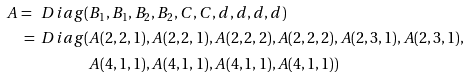<formula> <loc_0><loc_0><loc_500><loc_500>A = \ D i a g ( & B _ { 1 } , B _ { 1 } , B _ { 2 } , B _ { 2 } , C , C , d , d , d , d ) \\ = \ D i a g ( & A ( 2 , 2 , 1 ) , A ( 2 , 2 , 1 ) , A ( 2 , 2 , 2 ) , A ( 2 , 2 , 2 ) , A ( 2 , 3 , 1 ) , A ( 2 , 3 , 1 ) , \\ & A ( 4 , 1 , 1 ) , A ( 4 , 1 , 1 ) , A ( 4 , 1 , 1 ) , A ( 4 , 1 , 1 ) )</formula> 